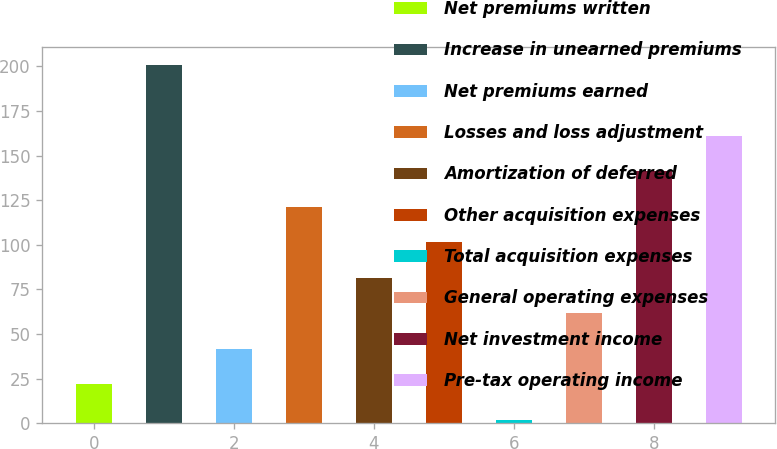Convert chart. <chart><loc_0><loc_0><loc_500><loc_500><bar_chart><fcel>Net premiums written<fcel>Increase in unearned premiums<fcel>Net premiums earned<fcel>Losses and loss adjustment<fcel>Amortization of deferred<fcel>Other acquisition expenses<fcel>Total acquisition expenses<fcel>General operating expenses<fcel>Net investment income<fcel>Pre-tax operating income<nl><fcel>21.9<fcel>201<fcel>41.8<fcel>121.4<fcel>81.6<fcel>101.5<fcel>2<fcel>61.7<fcel>141.3<fcel>161.2<nl></chart> 